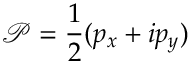Convert formula to latex. <formula><loc_0><loc_0><loc_500><loc_500>\mathcal { P } = \frac { 1 } { 2 } ( p _ { x } + i p _ { y } )</formula> 